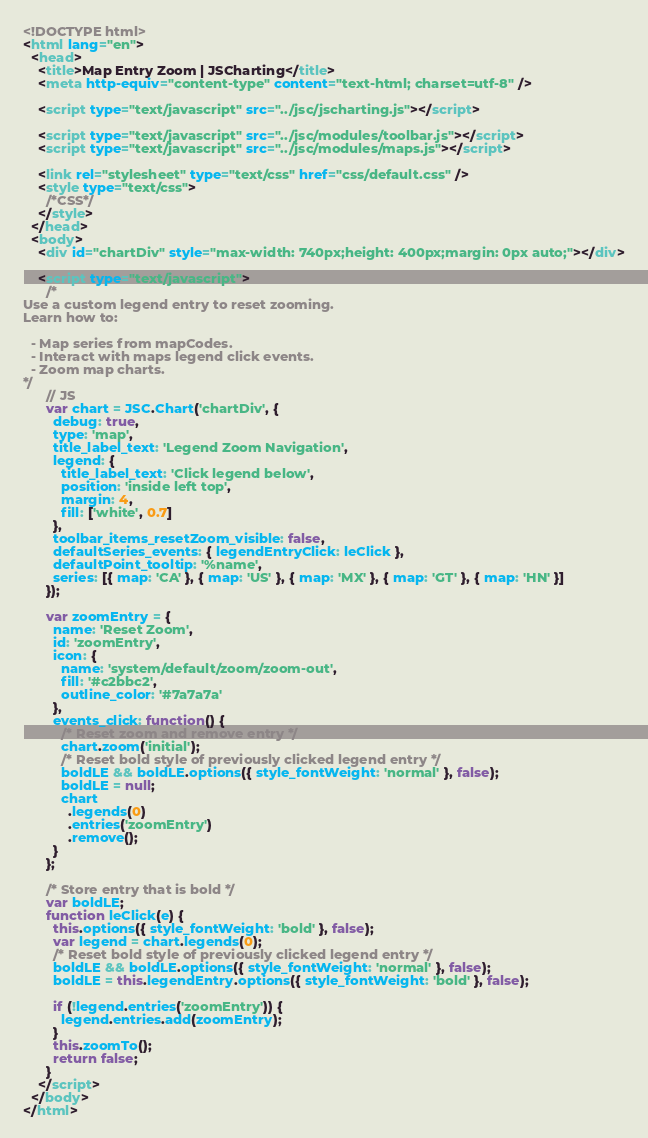Convert code to text. <code><loc_0><loc_0><loc_500><loc_500><_HTML_><!DOCTYPE html>
<html lang="en">
  <head>
    <title>Map Entry Zoom | JSCharting</title>
    <meta http-equiv="content-type" content="text-html; charset=utf-8" />

    <script type="text/javascript" src="../jsc/jscharting.js"></script>

    <script type="text/javascript" src="../jsc/modules/toolbar.js"></script>
    <script type="text/javascript" src="../jsc/modules/maps.js"></script>

    <link rel="stylesheet" type="text/css" href="css/default.css" />
    <style type="text/css">
      /*CSS*/
    </style>
  </head>
  <body>
    <div id="chartDiv" style="max-width: 740px;height: 400px;margin: 0px auto;"></div>

    <script type="text/javascript">
      /*
Use a custom legend entry to reset zooming.
Learn how to:

  - Map series from mapCodes.
  - Interact with maps legend click events.
  - Zoom map charts.
*/
      // JS
      var chart = JSC.Chart('chartDiv', {
        debug: true,
        type: 'map',
        title_label_text: 'Legend Zoom Navigation',
        legend: {
          title_label_text: 'Click legend below',
          position: 'inside left top',
          margin: 4,
          fill: ['white', 0.7]
        },
        toolbar_items_resetZoom_visible: false,
        defaultSeries_events: { legendEntryClick: leClick },
        defaultPoint_tooltip: '%name',
        series: [{ map: 'CA' }, { map: 'US' }, { map: 'MX' }, { map: 'GT' }, { map: 'HN' }]
      });

      var zoomEntry = {
        name: 'Reset Zoom',
        id: 'zoomEntry',
        icon: {
          name: 'system/default/zoom/zoom-out',
          fill: '#c2bbc2',
          outline_color: '#7a7a7a'
        },
        events_click: function() {
          /* Reset zoom and remove entry */
          chart.zoom('initial');
          /* Reset bold style of previously clicked legend entry */
          boldLE && boldLE.options({ style_fontWeight: 'normal' }, false);
          boldLE = null;
          chart
            .legends(0)
            .entries('zoomEntry')
            .remove();
        }
      };

      /* Store entry that is bold */
      var boldLE;
      function leClick(e) {
        this.options({ style_fontWeight: 'bold' }, false);
        var legend = chart.legends(0);
        /* Reset bold style of previously clicked legend entry */
        boldLE && boldLE.options({ style_fontWeight: 'normal' }, false);
        boldLE = this.legendEntry.options({ style_fontWeight: 'bold' }, false);

        if (!legend.entries('zoomEntry')) {
          legend.entries.add(zoomEntry);
        }
        this.zoomTo();
        return false;
      }
    </script>
  </body>
</html>
</code> 